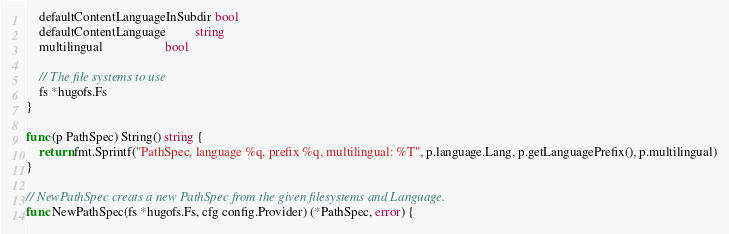<code> <loc_0><loc_0><loc_500><loc_500><_Go_>	defaultContentLanguageInSubdir bool
	defaultContentLanguage         string
	multilingual                   bool

	// The file systems to use
	fs *hugofs.Fs
}

func (p PathSpec) String() string {
	return fmt.Sprintf("PathSpec, language %q, prefix %q, multilingual: %T", p.language.Lang, p.getLanguagePrefix(), p.multilingual)
}

// NewPathSpec creats a new PathSpec from the given filesystems and Language.
func NewPathSpec(fs *hugofs.Fs, cfg config.Provider) (*PathSpec, error) {
</code> 